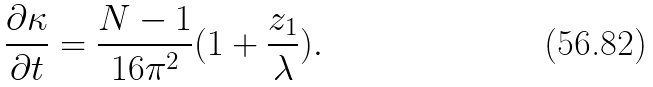Convert formula to latex. <formula><loc_0><loc_0><loc_500><loc_500>\frac { \partial \kappa } { \partial t } = \frac { N - 1 } { 1 6 \pi ^ { 2 } } ( 1 + \frac { z _ { 1 } } { \lambda } ) .</formula> 